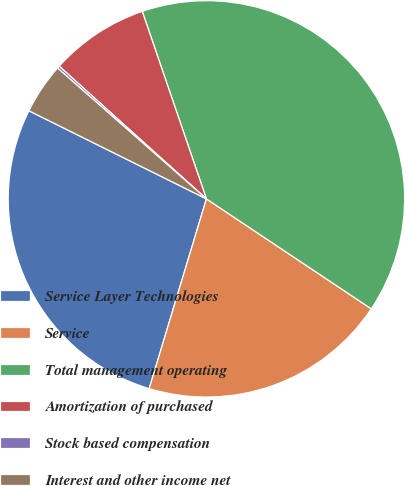Convert chart to OTSL. <chart><loc_0><loc_0><loc_500><loc_500><pie_chart><fcel>Service Layer Technologies<fcel>Service<fcel>Total management operating<fcel>Amortization of purchased<fcel>Stock based compensation<fcel>Interest and other income net<nl><fcel>27.67%<fcel>20.3%<fcel>39.61%<fcel>8.08%<fcel>0.2%<fcel>4.14%<nl></chart> 